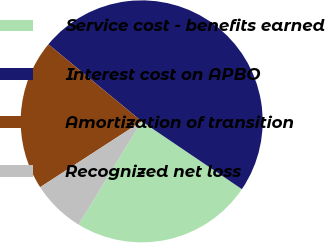Convert chart. <chart><loc_0><loc_0><loc_500><loc_500><pie_chart><fcel>Service cost - benefits earned<fcel>Interest cost on APBO<fcel>Amortization of transition<fcel>Recognized net loss<nl><fcel>24.27%<fcel>48.48%<fcel>20.14%<fcel>7.11%<nl></chart> 